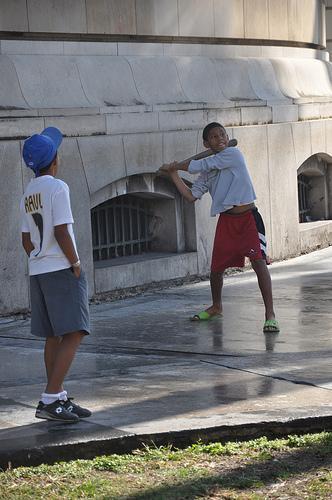How many people are pictured?
Give a very brief answer. 2. How many boys are wearing sneakers?
Give a very brief answer. 1. How many kids have on green shoes?
Give a very brief answer. 1. 